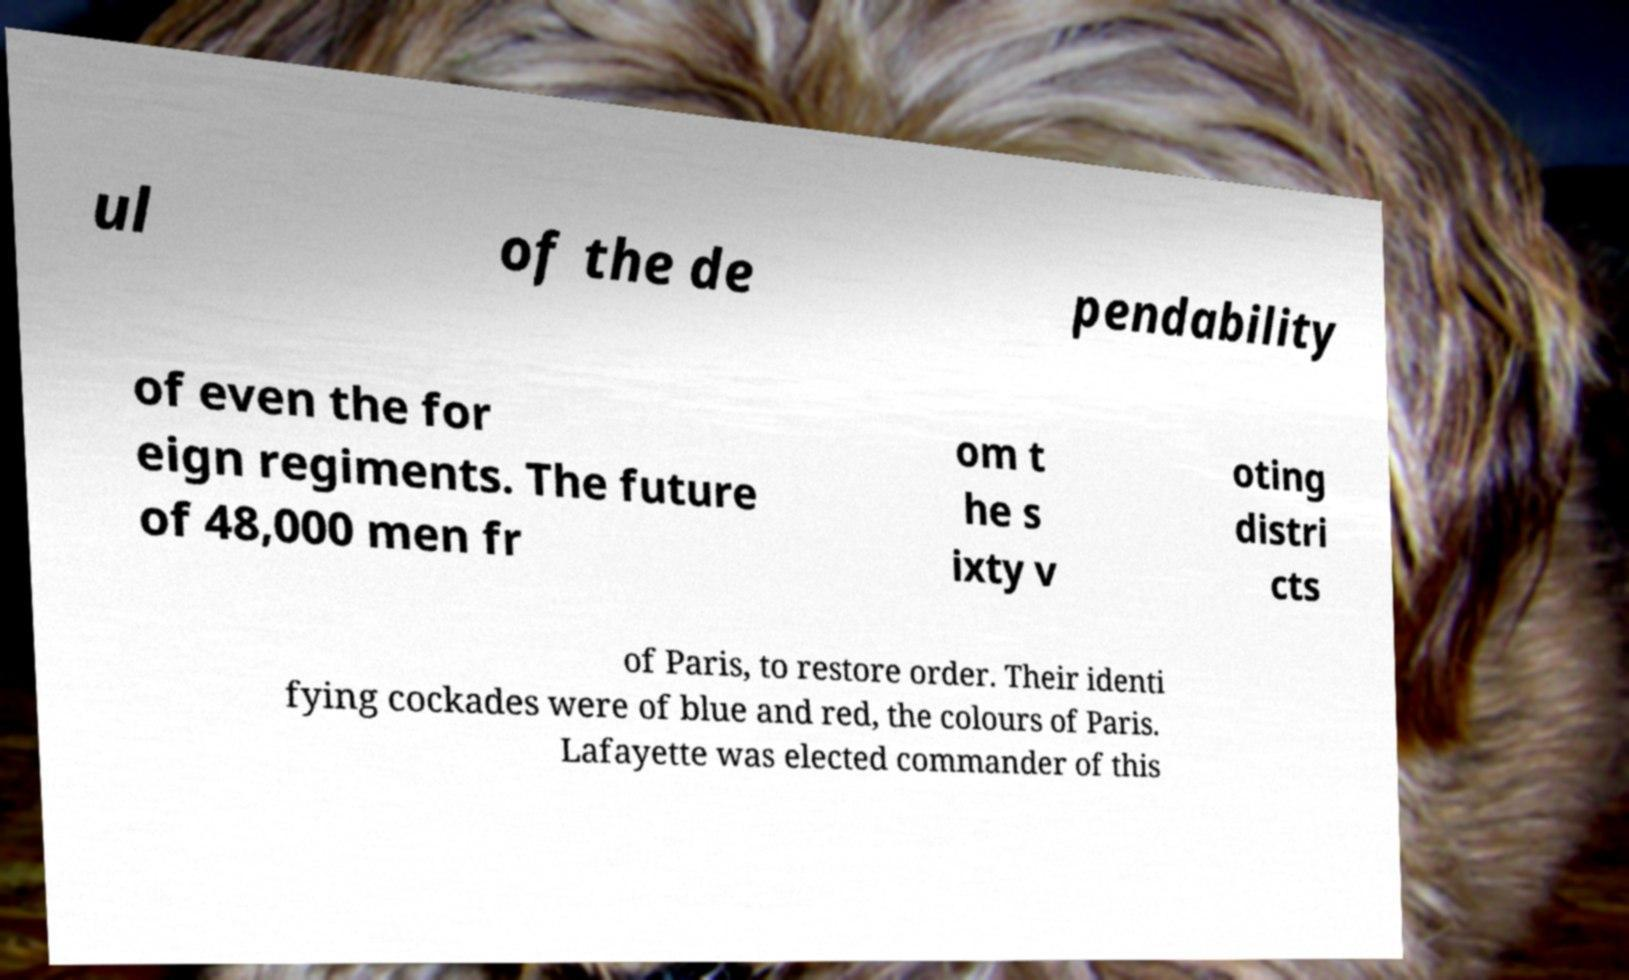What messages or text are displayed in this image? I need them in a readable, typed format. ul of the de pendability of even the for eign regiments. The future of 48,000 men fr om t he s ixty v oting distri cts of Paris, to restore order. Their identi fying cockades were of blue and red, the colours of Paris. Lafayette was elected commander of this 